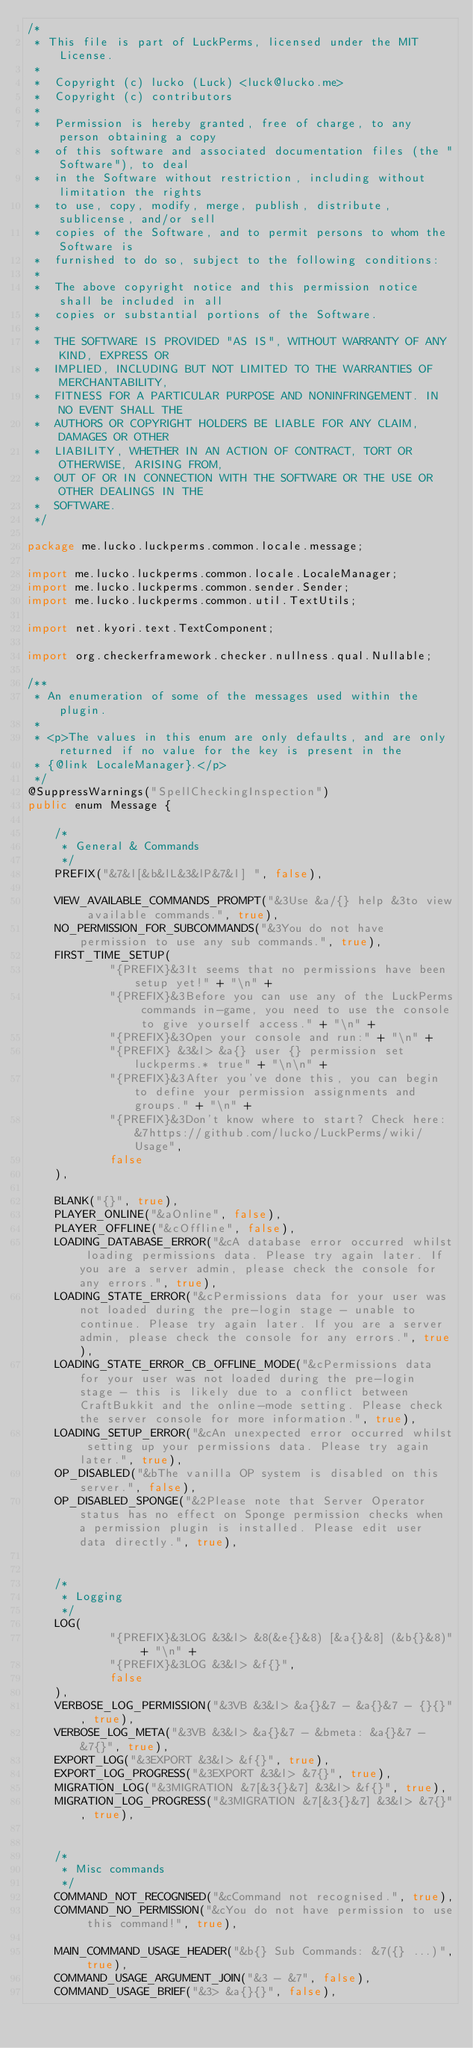Convert code to text. <code><loc_0><loc_0><loc_500><loc_500><_Java_>/*
 * This file is part of LuckPerms, licensed under the MIT License.
 *
 *  Copyright (c) lucko (Luck) <luck@lucko.me>
 *  Copyright (c) contributors
 *
 *  Permission is hereby granted, free of charge, to any person obtaining a copy
 *  of this software and associated documentation files (the "Software"), to deal
 *  in the Software without restriction, including without limitation the rights
 *  to use, copy, modify, merge, publish, distribute, sublicense, and/or sell
 *  copies of the Software, and to permit persons to whom the Software is
 *  furnished to do so, subject to the following conditions:
 *
 *  The above copyright notice and this permission notice shall be included in all
 *  copies or substantial portions of the Software.
 *
 *  THE SOFTWARE IS PROVIDED "AS IS", WITHOUT WARRANTY OF ANY KIND, EXPRESS OR
 *  IMPLIED, INCLUDING BUT NOT LIMITED TO THE WARRANTIES OF MERCHANTABILITY,
 *  FITNESS FOR A PARTICULAR PURPOSE AND NONINFRINGEMENT. IN NO EVENT SHALL THE
 *  AUTHORS OR COPYRIGHT HOLDERS BE LIABLE FOR ANY CLAIM, DAMAGES OR OTHER
 *  LIABILITY, WHETHER IN AN ACTION OF CONTRACT, TORT OR OTHERWISE, ARISING FROM,
 *  OUT OF OR IN CONNECTION WITH THE SOFTWARE OR THE USE OR OTHER DEALINGS IN THE
 *  SOFTWARE.
 */

package me.lucko.luckperms.common.locale.message;

import me.lucko.luckperms.common.locale.LocaleManager;
import me.lucko.luckperms.common.sender.Sender;
import me.lucko.luckperms.common.util.TextUtils;

import net.kyori.text.TextComponent;

import org.checkerframework.checker.nullness.qual.Nullable;

/**
 * An enumeration of some of the messages used within the plugin.
 *
 * <p>The values in this enum are only defaults, and are only returned if no value for the key is present in the
 * {@link LocaleManager}.</p>
 */
@SuppressWarnings("SpellCheckingInspection")
public enum Message {

    /*
     * General & Commands
     */
    PREFIX("&7&l[&b&lL&3&lP&7&l] ", false),

    VIEW_AVAILABLE_COMMANDS_PROMPT("&3Use &a/{} help &3to view available commands.", true),
    NO_PERMISSION_FOR_SUBCOMMANDS("&3You do not have permission to use any sub commands.", true),
    FIRST_TIME_SETUP(
            "{PREFIX}&3It seems that no permissions have been setup yet!" + "\n" +
            "{PREFIX}&3Before you can use any of the LuckPerms commands in-game, you need to use the console to give yourself access." + "\n" +
            "{PREFIX}&3Open your console and run:" + "\n" +
            "{PREFIX} &3&l> &a{} user {} permission set luckperms.* true" + "\n\n" +
            "{PREFIX}&3After you've done this, you can begin to define your permission assignments and groups." + "\n" +
            "{PREFIX}&3Don't know where to start? Check here: &7https://github.com/lucko/LuckPerms/wiki/Usage",
            false
    ),

    BLANK("{}", true),
    PLAYER_ONLINE("&aOnline", false),
    PLAYER_OFFLINE("&cOffline", false),
    LOADING_DATABASE_ERROR("&cA database error occurred whilst loading permissions data. Please try again later. If you are a server admin, please check the console for any errors.", true),
    LOADING_STATE_ERROR("&cPermissions data for your user was not loaded during the pre-login stage - unable to continue. Please try again later. If you are a server admin, please check the console for any errors.", true),
    LOADING_STATE_ERROR_CB_OFFLINE_MODE("&cPermissions data for your user was not loaded during the pre-login stage - this is likely due to a conflict between CraftBukkit and the online-mode setting. Please check the server console for more information.", true),
    LOADING_SETUP_ERROR("&cAn unexpected error occurred whilst setting up your permissions data. Please try again later.", true),
    OP_DISABLED("&bThe vanilla OP system is disabled on this server.", false),
    OP_DISABLED_SPONGE("&2Please note that Server Operator status has no effect on Sponge permission checks when a permission plugin is installed. Please edit user data directly.", true),


    /*
     * Logging
     */
    LOG(
            "{PREFIX}&3LOG &3&l> &8(&e{}&8) [&a{}&8] (&b{}&8)" + "\n" +
            "{PREFIX}&3LOG &3&l> &f{}",
            false
    ),
    VERBOSE_LOG_PERMISSION("&3VB &3&l> &a{}&7 - &a{}&7 - {}{}", true),
    VERBOSE_LOG_META("&3VB &3&l> &a{}&7 - &bmeta: &a{}&7 - &7{}", true),
    EXPORT_LOG("&3EXPORT &3&l> &f{}", true),
    EXPORT_LOG_PROGRESS("&3EXPORT &3&l> &7{}", true),
    MIGRATION_LOG("&3MIGRATION &7[&3{}&7] &3&l> &f{}", true),
    MIGRATION_LOG_PROGRESS("&3MIGRATION &7[&3{}&7] &3&l> &7{}", true),


    /*
     * Misc commands
     */
    COMMAND_NOT_RECOGNISED("&cCommand not recognised.", true),
    COMMAND_NO_PERMISSION("&cYou do not have permission to use this command!", true),

    MAIN_COMMAND_USAGE_HEADER("&b{} Sub Commands: &7({} ...)", true),
    COMMAND_USAGE_ARGUMENT_JOIN("&3 - &7", false),
    COMMAND_USAGE_BRIEF("&3> &a{}{}", false),</code> 